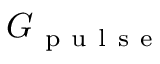Convert formula to latex. <formula><loc_0><loc_0><loc_500><loc_500>G _ { p u l s e }</formula> 